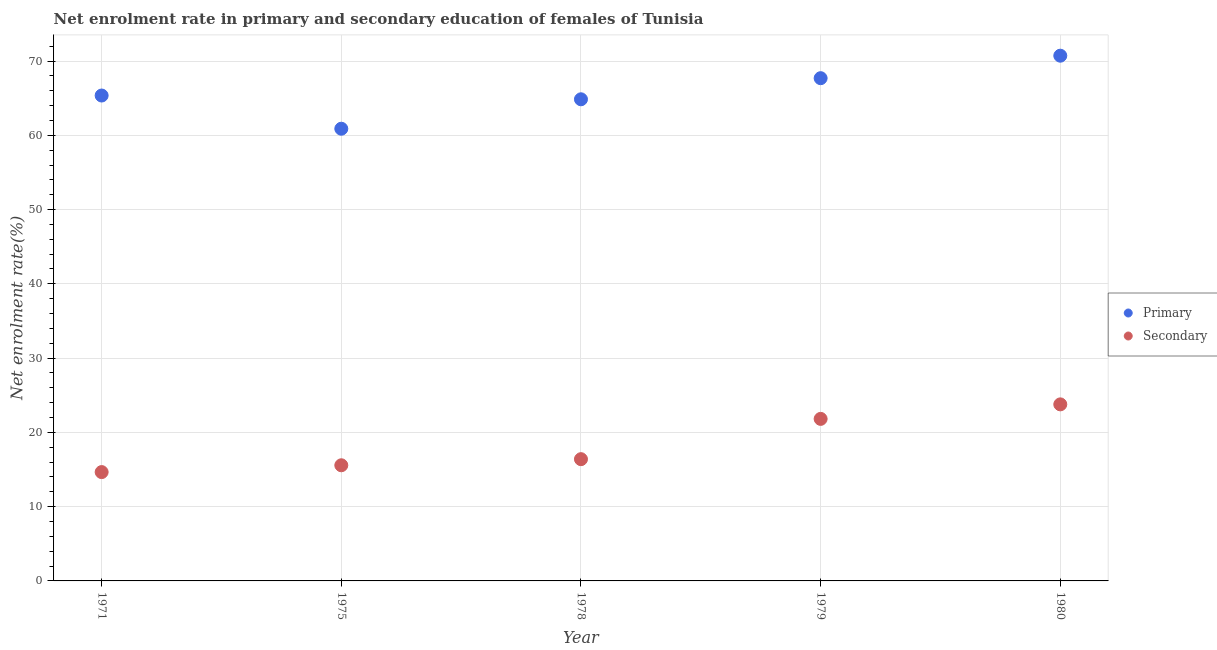How many different coloured dotlines are there?
Give a very brief answer. 2. What is the enrollment rate in primary education in 1971?
Ensure brevity in your answer.  65.35. Across all years, what is the maximum enrollment rate in primary education?
Give a very brief answer. 70.72. Across all years, what is the minimum enrollment rate in secondary education?
Provide a succinct answer. 14.65. In which year was the enrollment rate in secondary education maximum?
Keep it short and to the point. 1980. What is the total enrollment rate in primary education in the graph?
Your response must be concise. 329.5. What is the difference between the enrollment rate in secondary education in 1971 and that in 1980?
Keep it short and to the point. -9.12. What is the difference between the enrollment rate in secondary education in 1975 and the enrollment rate in primary education in 1979?
Offer a very short reply. -52.12. What is the average enrollment rate in secondary education per year?
Keep it short and to the point. 18.44. In the year 1978, what is the difference between the enrollment rate in primary education and enrollment rate in secondary education?
Your response must be concise. 48.46. In how many years, is the enrollment rate in primary education greater than 52 %?
Offer a very short reply. 5. What is the ratio of the enrollment rate in primary education in 1978 to that in 1980?
Provide a succinct answer. 0.92. Is the enrollment rate in secondary education in 1975 less than that in 1978?
Your response must be concise. Yes. What is the difference between the highest and the second highest enrollment rate in primary education?
Offer a very short reply. 3.03. What is the difference between the highest and the lowest enrollment rate in secondary education?
Keep it short and to the point. 9.12. Does the enrollment rate in secondary education monotonically increase over the years?
Offer a terse response. Yes. Is the enrollment rate in primary education strictly greater than the enrollment rate in secondary education over the years?
Offer a very short reply. Yes. Is the enrollment rate in secondary education strictly less than the enrollment rate in primary education over the years?
Your answer should be compact. Yes. How many dotlines are there?
Your answer should be very brief. 2. How many years are there in the graph?
Provide a succinct answer. 5. What is the difference between two consecutive major ticks on the Y-axis?
Your answer should be compact. 10. Does the graph contain grids?
Provide a short and direct response. Yes. What is the title of the graph?
Make the answer very short. Net enrolment rate in primary and secondary education of females of Tunisia. What is the label or title of the Y-axis?
Offer a very short reply. Net enrolment rate(%). What is the Net enrolment rate(%) of Primary in 1971?
Your response must be concise. 65.35. What is the Net enrolment rate(%) in Secondary in 1971?
Provide a short and direct response. 14.65. What is the Net enrolment rate(%) of Primary in 1975?
Your response must be concise. 60.88. What is the Net enrolment rate(%) in Secondary in 1975?
Your answer should be compact. 15.57. What is the Net enrolment rate(%) of Primary in 1978?
Keep it short and to the point. 64.85. What is the Net enrolment rate(%) of Secondary in 1978?
Make the answer very short. 16.39. What is the Net enrolment rate(%) in Primary in 1979?
Make the answer very short. 67.69. What is the Net enrolment rate(%) in Secondary in 1979?
Keep it short and to the point. 21.82. What is the Net enrolment rate(%) in Primary in 1980?
Your response must be concise. 70.72. What is the Net enrolment rate(%) in Secondary in 1980?
Keep it short and to the point. 23.77. Across all years, what is the maximum Net enrolment rate(%) in Primary?
Your answer should be very brief. 70.72. Across all years, what is the maximum Net enrolment rate(%) of Secondary?
Offer a very short reply. 23.77. Across all years, what is the minimum Net enrolment rate(%) in Primary?
Give a very brief answer. 60.88. Across all years, what is the minimum Net enrolment rate(%) of Secondary?
Ensure brevity in your answer.  14.65. What is the total Net enrolment rate(%) in Primary in the graph?
Keep it short and to the point. 329.5. What is the total Net enrolment rate(%) of Secondary in the graph?
Make the answer very short. 92.21. What is the difference between the Net enrolment rate(%) in Primary in 1971 and that in 1975?
Offer a very short reply. 4.47. What is the difference between the Net enrolment rate(%) in Secondary in 1971 and that in 1975?
Your answer should be very brief. -0.92. What is the difference between the Net enrolment rate(%) in Primary in 1971 and that in 1978?
Your response must be concise. 0.51. What is the difference between the Net enrolment rate(%) in Secondary in 1971 and that in 1978?
Make the answer very short. -1.74. What is the difference between the Net enrolment rate(%) in Primary in 1971 and that in 1979?
Provide a short and direct response. -2.34. What is the difference between the Net enrolment rate(%) of Secondary in 1971 and that in 1979?
Offer a very short reply. -7.16. What is the difference between the Net enrolment rate(%) in Primary in 1971 and that in 1980?
Make the answer very short. -5.36. What is the difference between the Net enrolment rate(%) of Secondary in 1971 and that in 1980?
Offer a terse response. -9.12. What is the difference between the Net enrolment rate(%) of Primary in 1975 and that in 1978?
Provide a succinct answer. -3.96. What is the difference between the Net enrolment rate(%) in Secondary in 1975 and that in 1978?
Ensure brevity in your answer.  -0.82. What is the difference between the Net enrolment rate(%) in Primary in 1975 and that in 1979?
Provide a short and direct response. -6.8. What is the difference between the Net enrolment rate(%) in Secondary in 1975 and that in 1979?
Offer a very short reply. -6.25. What is the difference between the Net enrolment rate(%) in Primary in 1975 and that in 1980?
Your response must be concise. -9.83. What is the difference between the Net enrolment rate(%) of Secondary in 1975 and that in 1980?
Give a very brief answer. -8.2. What is the difference between the Net enrolment rate(%) in Primary in 1978 and that in 1979?
Your answer should be very brief. -2.84. What is the difference between the Net enrolment rate(%) of Secondary in 1978 and that in 1979?
Provide a short and direct response. -5.42. What is the difference between the Net enrolment rate(%) of Primary in 1978 and that in 1980?
Your answer should be compact. -5.87. What is the difference between the Net enrolment rate(%) of Secondary in 1978 and that in 1980?
Your answer should be very brief. -7.38. What is the difference between the Net enrolment rate(%) of Primary in 1979 and that in 1980?
Give a very brief answer. -3.03. What is the difference between the Net enrolment rate(%) in Secondary in 1979 and that in 1980?
Provide a short and direct response. -1.96. What is the difference between the Net enrolment rate(%) of Primary in 1971 and the Net enrolment rate(%) of Secondary in 1975?
Give a very brief answer. 49.78. What is the difference between the Net enrolment rate(%) in Primary in 1971 and the Net enrolment rate(%) in Secondary in 1978?
Your answer should be compact. 48.96. What is the difference between the Net enrolment rate(%) of Primary in 1971 and the Net enrolment rate(%) of Secondary in 1979?
Provide a succinct answer. 43.54. What is the difference between the Net enrolment rate(%) in Primary in 1971 and the Net enrolment rate(%) in Secondary in 1980?
Make the answer very short. 41.58. What is the difference between the Net enrolment rate(%) of Primary in 1975 and the Net enrolment rate(%) of Secondary in 1978?
Provide a short and direct response. 44.49. What is the difference between the Net enrolment rate(%) in Primary in 1975 and the Net enrolment rate(%) in Secondary in 1979?
Offer a terse response. 39.07. What is the difference between the Net enrolment rate(%) of Primary in 1975 and the Net enrolment rate(%) of Secondary in 1980?
Offer a terse response. 37.11. What is the difference between the Net enrolment rate(%) of Primary in 1978 and the Net enrolment rate(%) of Secondary in 1979?
Give a very brief answer. 43.03. What is the difference between the Net enrolment rate(%) in Primary in 1978 and the Net enrolment rate(%) in Secondary in 1980?
Your answer should be very brief. 41.08. What is the difference between the Net enrolment rate(%) in Primary in 1979 and the Net enrolment rate(%) in Secondary in 1980?
Keep it short and to the point. 43.92. What is the average Net enrolment rate(%) of Primary per year?
Make the answer very short. 65.9. What is the average Net enrolment rate(%) of Secondary per year?
Offer a very short reply. 18.44. In the year 1971, what is the difference between the Net enrolment rate(%) in Primary and Net enrolment rate(%) in Secondary?
Provide a short and direct response. 50.7. In the year 1975, what is the difference between the Net enrolment rate(%) in Primary and Net enrolment rate(%) in Secondary?
Make the answer very short. 45.31. In the year 1978, what is the difference between the Net enrolment rate(%) of Primary and Net enrolment rate(%) of Secondary?
Your answer should be very brief. 48.46. In the year 1979, what is the difference between the Net enrolment rate(%) of Primary and Net enrolment rate(%) of Secondary?
Offer a very short reply. 45.87. In the year 1980, what is the difference between the Net enrolment rate(%) of Primary and Net enrolment rate(%) of Secondary?
Make the answer very short. 46.95. What is the ratio of the Net enrolment rate(%) of Primary in 1971 to that in 1975?
Give a very brief answer. 1.07. What is the ratio of the Net enrolment rate(%) in Secondary in 1971 to that in 1975?
Offer a terse response. 0.94. What is the ratio of the Net enrolment rate(%) of Primary in 1971 to that in 1978?
Your response must be concise. 1.01. What is the ratio of the Net enrolment rate(%) of Secondary in 1971 to that in 1978?
Provide a succinct answer. 0.89. What is the ratio of the Net enrolment rate(%) in Primary in 1971 to that in 1979?
Ensure brevity in your answer.  0.97. What is the ratio of the Net enrolment rate(%) of Secondary in 1971 to that in 1979?
Ensure brevity in your answer.  0.67. What is the ratio of the Net enrolment rate(%) in Primary in 1971 to that in 1980?
Offer a very short reply. 0.92. What is the ratio of the Net enrolment rate(%) in Secondary in 1971 to that in 1980?
Make the answer very short. 0.62. What is the ratio of the Net enrolment rate(%) in Primary in 1975 to that in 1978?
Give a very brief answer. 0.94. What is the ratio of the Net enrolment rate(%) in Secondary in 1975 to that in 1978?
Ensure brevity in your answer.  0.95. What is the ratio of the Net enrolment rate(%) of Primary in 1975 to that in 1979?
Provide a short and direct response. 0.9. What is the ratio of the Net enrolment rate(%) in Secondary in 1975 to that in 1979?
Provide a succinct answer. 0.71. What is the ratio of the Net enrolment rate(%) in Primary in 1975 to that in 1980?
Make the answer very short. 0.86. What is the ratio of the Net enrolment rate(%) in Secondary in 1975 to that in 1980?
Your answer should be very brief. 0.66. What is the ratio of the Net enrolment rate(%) of Primary in 1978 to that in 1979?
Your answer should be compact. 0.96. What is the ratio of the Net enrolment rate(%) of Secondary in 1978 to that in 1979?
Give a very brief answer. 0.75. What is the ratio of the Net enrolment rate(%) of Primary in 1978 to that in 1980?
Provide a short and direct response. 0.92. What is the ratio of the Net enrolment rate(%) of Secondary in 1978 to that in 1980?
Make the answer very short. 0.69. What is the ratio of the Net enrolment rate(%) of Primary in 1979 to that in 1980?
Make the answer very short. 0.96. What is the ratio of the Net enrolment rate(%) in Secondary in 1979 to that in 1980?
Your response must be concise. 0.92. What is the difference between the highest and the second highest Net enrolment rate(%) of Primary?
Offer a terse response. 3.03. What is the difference between the highest and the second highest Net enrolment rate(%) in Secondary?
Offer a very short reply. 1.96. What is the difference between the highest and the lowest Net enrolment rate(%) of Primary?
Your response must be concise. 9.83. What is the difference between the highest and the lowest Net enrolment rate(%) of Secondary?
Ensure brevity in your answer.  9.12. 